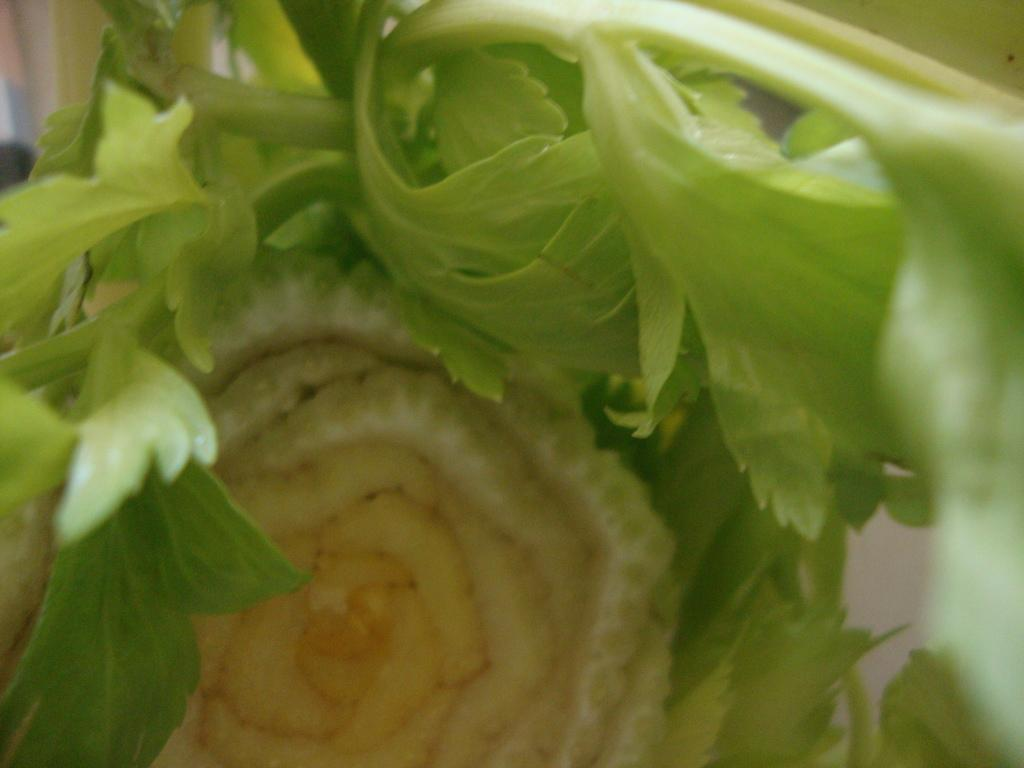What is the main subject of the image? There is a flower in the image. Can you describe the color of the flower? The flower is cream-colored. Is the flower part of a larger plant? Yes, the flower is attached to a plant. What is the color of the plant? The plant is green. What credit score does the flower have in the image? There is no information about credit scores in the image, as it features a flower and a plant. 